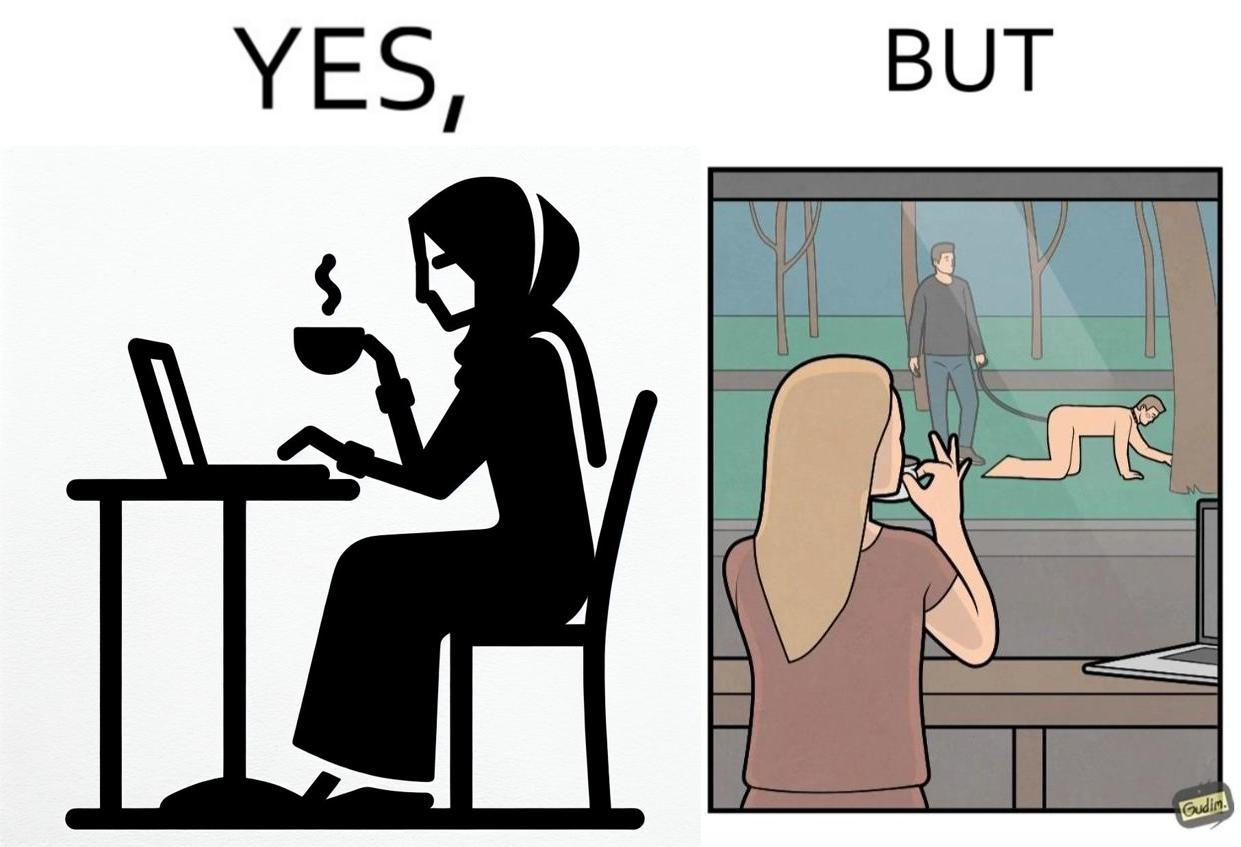What do you see in each half of this image? In the left part of the image: a woman inside a cafe enjoying a cup of some hot drink while doing her work on a laptop and watching outside through the window In the right part of the image: a person at some cafe, while looking at an act of slavery outside through the window 